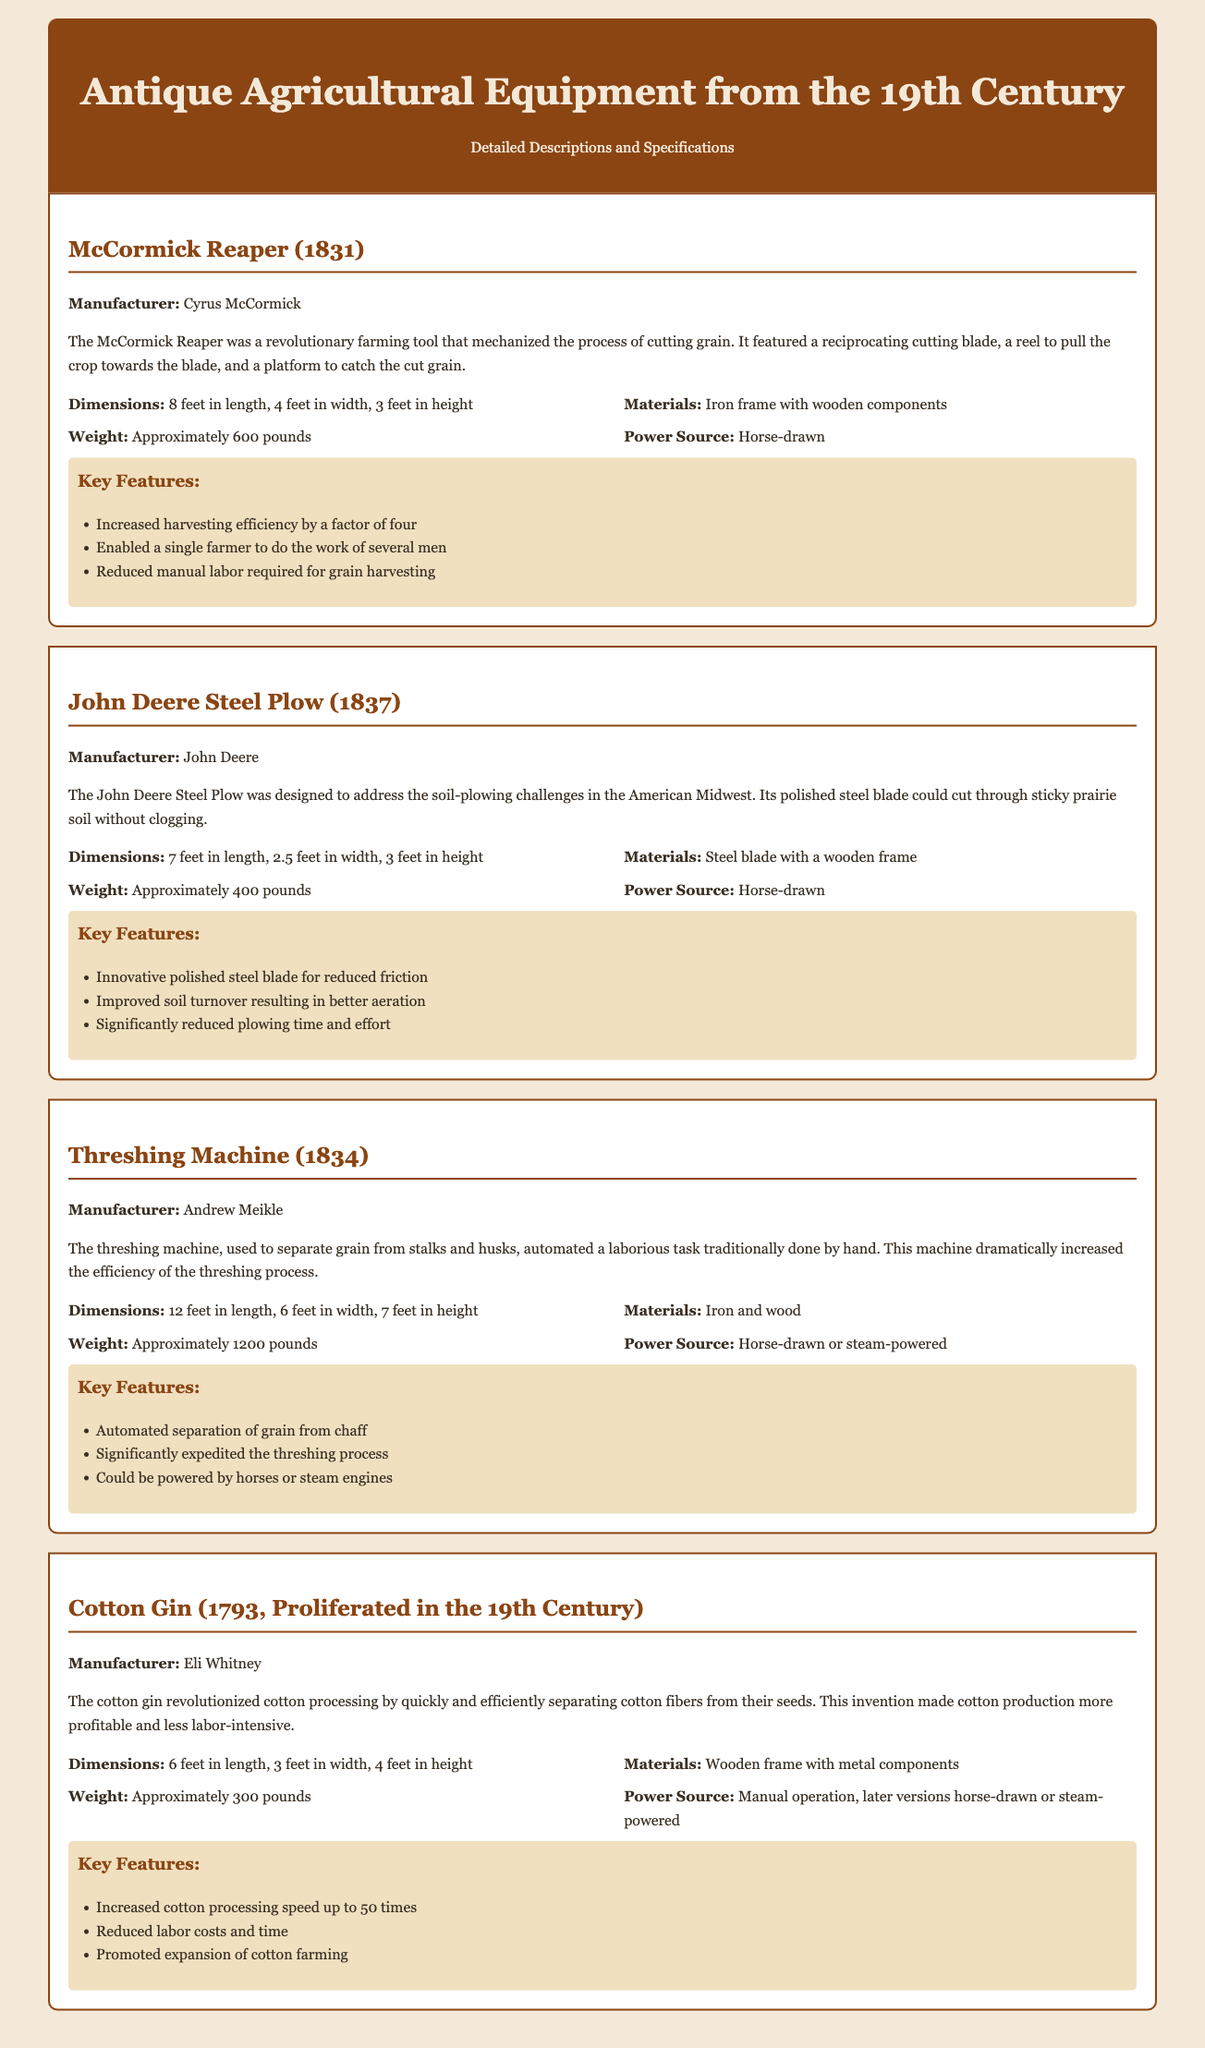What year was the McCormick Reaper invented? The document states that the McCormick Reaper was invented in 1831.
Answer: 1831 Who was the manufacturer of the John Deere Steel Plow? The document identifies the manufacturer of the John Deere Steel Plow as John Deere.
Answer: John Deere What is the weight of the Threshing Machine? According to the document, the weight of the Threshing Machine is approximately 1200 pounds.
Answer: Approximately 1200 pounds What is one key feature of the Cotton Gin? The document lists several key features, one of which is "Increased cotton processing speed up to 50 times."
Answer: Increased cotton processing speed up to 50 times How many feet long is the McCormick Reaper? The specifications indicate that the McCormick Reaper is 8 feet in length.
Answer: 8 feet What materials are used in the construction of the John Deere Steel Plow? The document specifies that the materials for the John Deere Steel Plow consist of a steel blade with a wooden frame.
Answer: Steel blade with a wooden frame Which agricultural equipment can be powered by steam? The Threshing Machine can be powered by steam as per the document’s details.
Answer: Threshing Machine What significant advancement did the Cotton Gin bring to cotton processing? The document explains that the Cotton Gin brought significant advancements by making cotton production more profitable and less labor-intensive.
Answer: More profitable and less labor-intensive 